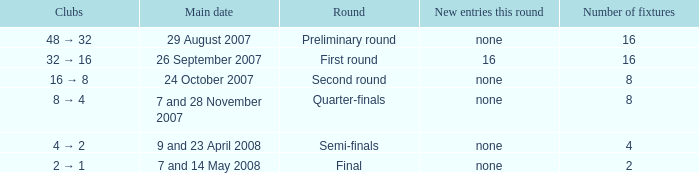What is the New entries this round when the round is the semi-finals? None. 